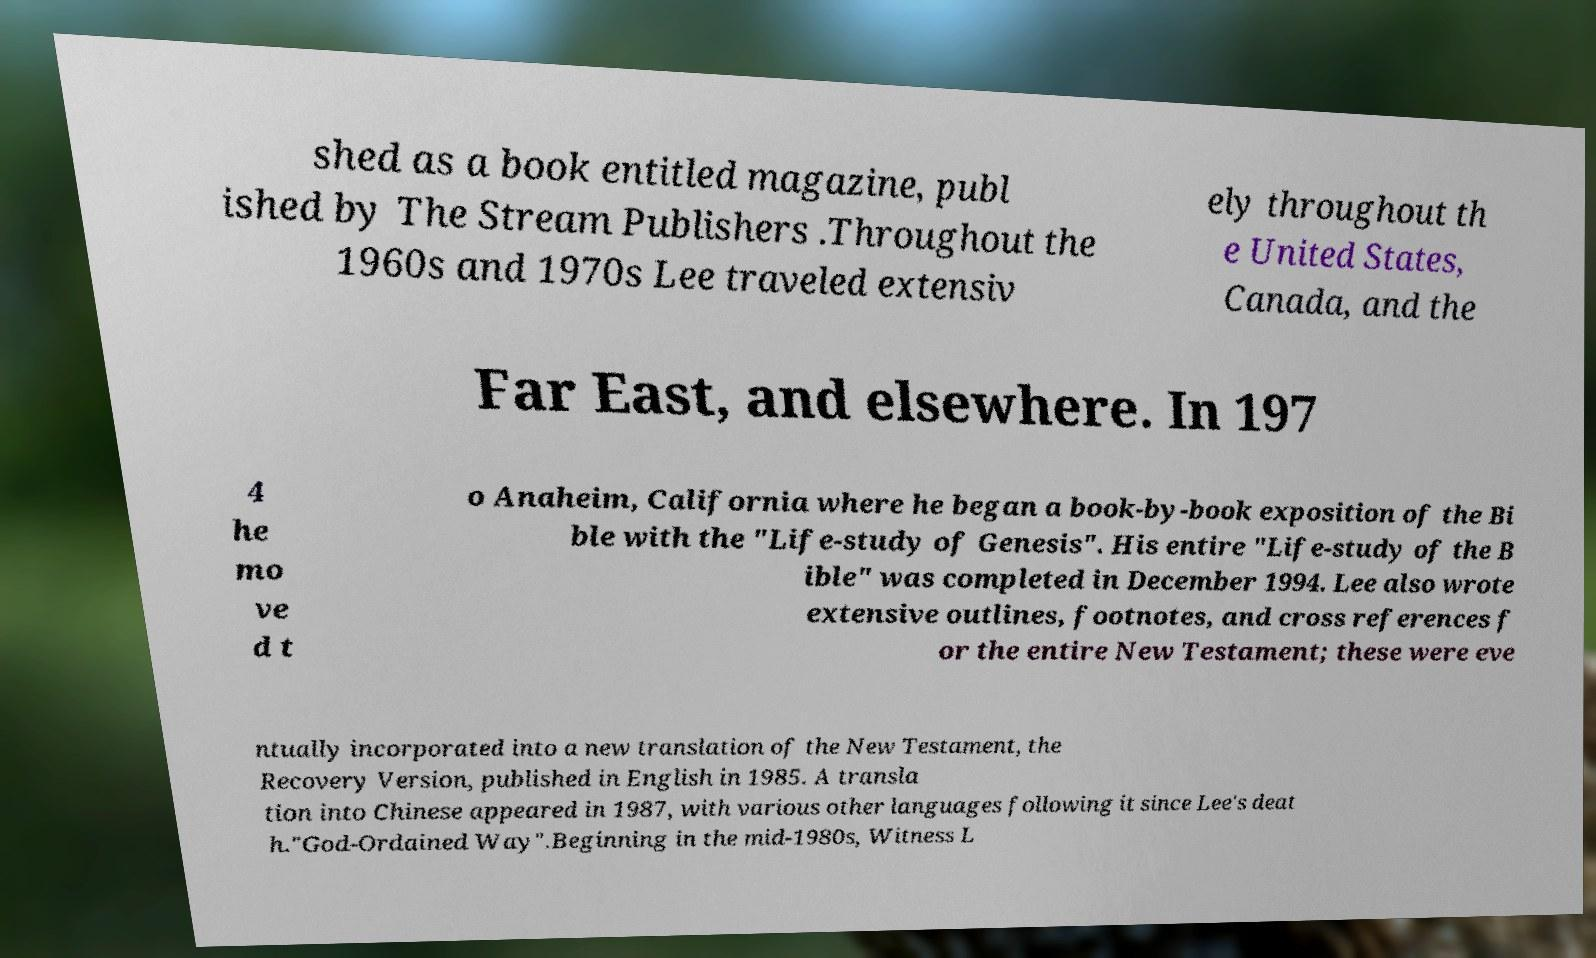For documentation purposes, I need the text within this image transcribed. Could you provide that? shed as a book entitled magazine, publ ished by The Stream Publishers .Throughout the 1960s and 1970s Lee traveled extensiv ely throughout th e United States, Canada, and the Far East, and elsewhere. In 197 4 he mo ve d t o Anaheim, California where he began a book-by-book exposition of the Bi ble with the "Life-study of Genesis". His entire "Life-study of the B ible" was completed in December 1994. Lee also wrote extensive outlines, footnotes, and cross references f or the entire New Testament; these were eve ntually incorporated into a new translation of the New Testament, the Recovery Version, published in English in 1985. A transla tion into Chinese appeared in 1987, with various other languages following it since Lee's deat h."God-Ordained Way".Beginning in the mid-1980s, Witness L 